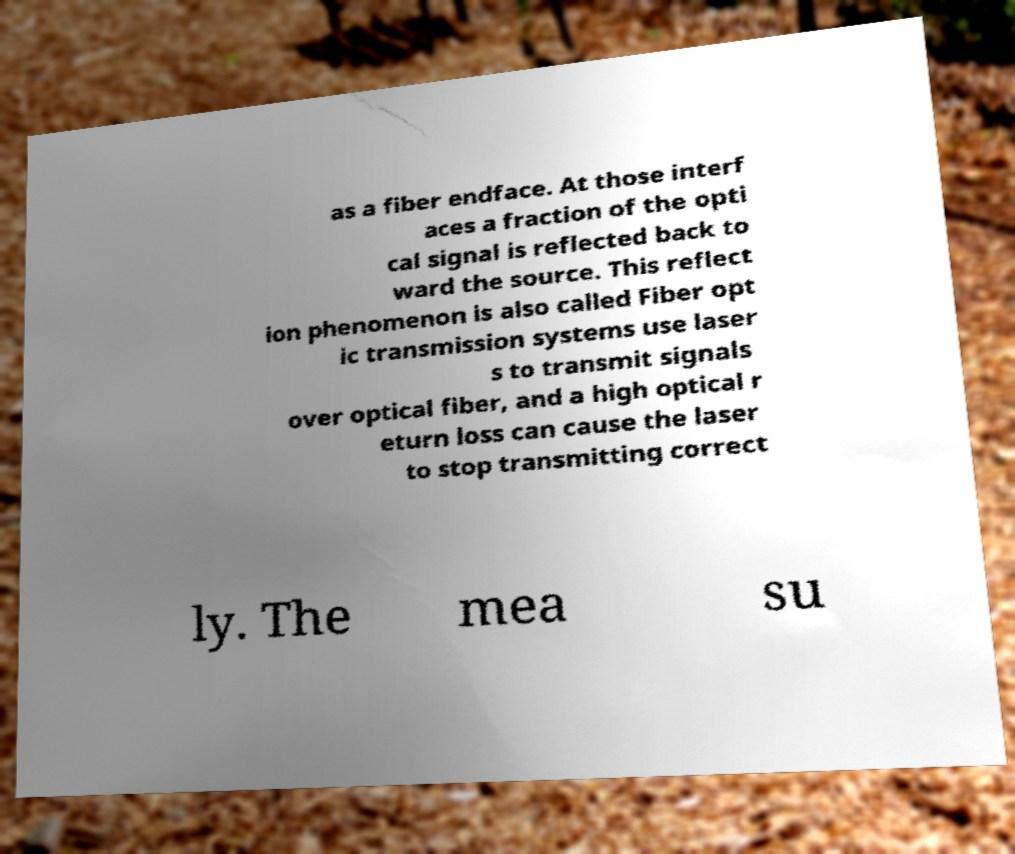Can you read and provide the text displayed in the image?This photo seems to have some interesting text. Can you extract and type it out for me? as a fiber endface. At those interf aces a fraction of the opti cal signal is reflected back to ward the source. This reflect ion phenomenon is also called Fiber opt ic transmission systems use laser s to transmit signals over optical fiber, and a high optical r eturn loss can cause the laser to stop transmitting correct ly. The mea su 